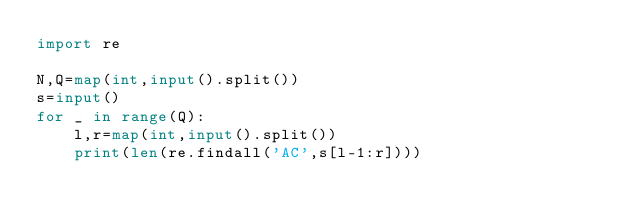Convert code to text. <code><loc_0><loc_0><loc_500><loc_500><_Python_>import re

N,Q=map(int,input().split())
s=input()
for _ in range(Q):
    l,r=map(int,input().split())
    print(len(re.findall('AC',s[l-1:r])))</code> 